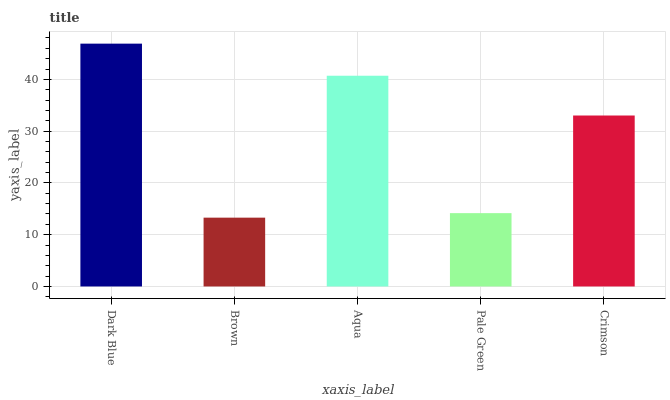Is Aqua the minimum?
Answer yes or no. No. Is Aqua the maximum?
Answer yes or no. No. Is Aqua greater than Brown?
Answer yes or no. Yes. Is Brown less than Aqua?
Answer yes or no. Yes. Is Brown greater than Aqua?
Answer yes or no. No. Is Aqua less than Brown?
Answer yes or no. No. Is Crimson the high median?
Answer yes or no. Yes. Is Crimson the low median?
Answer yes or no. Yes. Is Pale Green the high median?
Answer yes or no. No. Is Pale Green the low median?
Answer yes or no. No. 